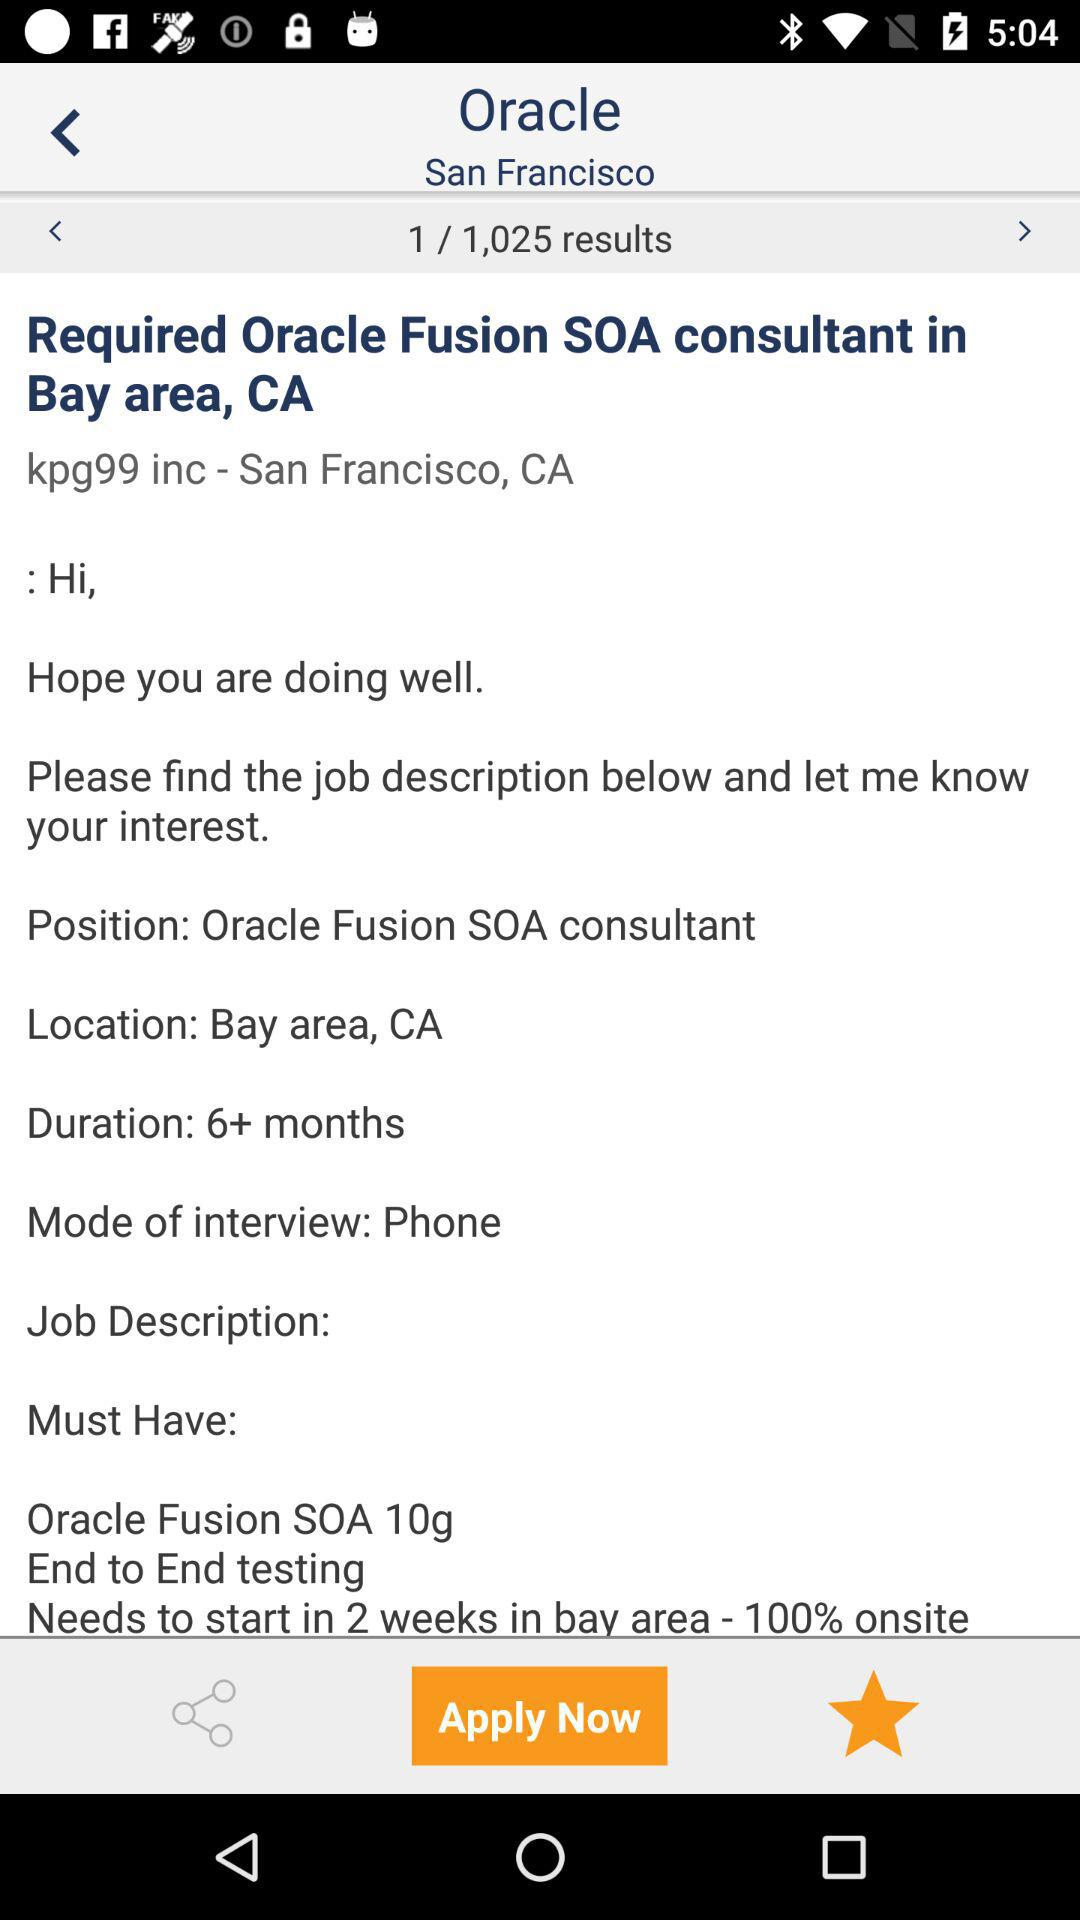What is the location? The location is the Bay Area, CA. 